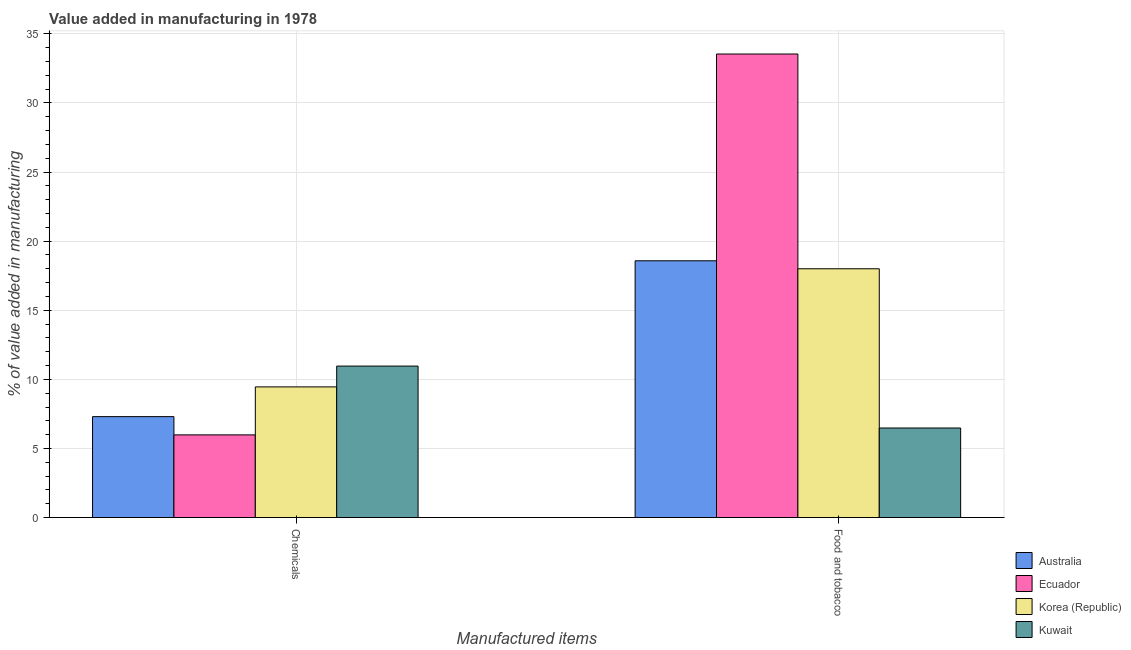How many groups of bars are there?
Give a very brief answer. 2. Are the number of bars on each tick of the X-axis equal?
Your answer should be compact. Yes. What is the label of the 2nd group of bars from the left?
Offer a very short reply. Food and tobacco. What is the value added by  manufacturing chemicals in Australia?
Offer a very short reply. 7.3. Across all countries, what is the maximum value added by  manufacturing chemicals?
Your answer should be very brief. 10.96. Across all countries, what is the minimum value added by  manufacturing chemicals?
Make the answer very short. 5.98. In which country was the value added by  manufacturing chemicals maximum?
Keep it short and to the point. Kuwait. In which country was the value added by  manufacturing chemicals minimum?
Your answer should be very brief. Ecuador. What is the total value added by  manufacturing chemicals in the graph?
Provide a short and direct response. 33.7. What is the difference between the value added by  manufacturing chemicals in Australia and that in Kuwait?
Offer a very short reply. -3.66. What is the difference between the value added by  manufacturing chemicals in Korea (Republic) and the value added by manufacturing food and tobacco in Australia?
Ensure brevity in your answer.  -9.12. What is the average value added by  manufacturing chemicals per country?
Offer a very short reply. 8.43. What is the difference between the value added by  manufacturing chemicals and value added by manufacturing food and tobacco in Kuwait?
Make the answer very short. 4.48. What is the ratio of the value added by manufacturing food and tobacco in Australia to that in Ecuador?
Provide a short and direct response. 0.55. What does the 2nd bar from the left in Chemicals represents?
Ensure brevity in your answer.  Ecuador. What is the difference between two consecutive major ticks on the Y-axis?
Provide a succinct answer. 5. Does the graph contain any zero values?
Your answer should be compact. No. Does the graph contain grids?
Your response must be concise. Yes. What is the title of the graph?
Your answer should be very brief. Value added in manufacturing in 1978. Does "Uzbekistan" appear as one of the legend labels in the graph?
Keep it short and to the point. No. What is the label or title of the X-axis?
Offer a terse response. Manufactured items. What is the label or title of the Y-axis?
Give a very brief answer. % of value added in manufacturing. What is the % of value added in manufacturing in Australia in Chemicals?
Your response must be concise. 7.3. What is the % of value added in manufacturing in Ecuador in Chemicals?
Offer a terse response. 5.98. What is the % of value added in manufacturing in Korea (Republic) in Chemicals?
Give a very brief answer. 9.46. What is the % of value added in manufacturing of Kuwait in Chemicals?
Provide a succinct answer. 10.96. What is the % of value added in manufacturing of Australia in Food and tobacco?
Your answer should be compact. 18.58. What is the % of value added in manufacturing of Ecuador in Food and tobacco?
Provide a short and direct response. 33.54. What is the % of value added in manufacturing of Korea (Republic) in Food and tobacco?
Give a very brief answer. 18. What is the % of value added in manufacturing in Kuwait in Food and tobacco?
Make the answer very short. 6.48. Across all Manufactured items, what is the maximum % of value added in manufacturing in Australia?
Keep it short and to the point. 18.58. Across all Manufactured items, what is the maximum % of value added in manufacturing of Ecuador?
Provide a short and direct response. 33.54. Across all Manufactured items, what is the maximum % of value added in manufacturing of Korea (Republic)?
Your answer should be compact. 18. Across all Manufactured items, what is the maximum % of value added in manufacturing of Kuwait?
Your answer should be very brief. 10.96. Across all Manufactured items, what is the minimum % of value added in manufacturing of Australia?
Your answer should be compact. 7.3. Across all Manufactured items, what is the minimum % of value added in manufacturing of Ecuador?
Make the answer very short. 5.98. Across all Manufactured items, what is the minimum % of value added in manufacturing in Korea (Republic)?
Your answer should be compact. 9.46. Across all Manufactured items, what is the minimum % of value added in manufacturing in Kuwait?
Make the answer very short. 6.48. What is the total % of value added in manufacturing in Australia in the graph?
Your response must be concise. 25.88. What is the total % of value added in manufacturing of Ecuador in the graph?
Ensure brevity in your answer.  39.53. What is the total % of value added in manufacturing of Korea (Republic) in the graph?
Provide a succinct answer. 27.46. What is the total % of value added in manufacturing in Kuwait in the graph?
Your answer should be compact. 17.44. What is the difference between the % of value added in manufacturing in Australia in Chemicals and that in Food and tobacco?
Provide a short and direct response. -11.28. What is the difference between the % of value added in manufacturing of Ecuador in Chemicals and that in Food and tobacco?
Your answer should be very brief. -27.56. What is the difference between the % of value added in manufacturing of Korea (Republic) in Chemicals and that in Food and tobacco?
Give a very brief answer. -8.55. What is the difference between the % of value added in manufacturing of Kuwait in Chemicals and that in Food and tobacco?
Provide a succinct answer. 4.48. What is the difference between the % of value added in manufacturing of Australia in Chemicals and the % of value added in manufacturing of Ecuador in Food and tobacco?
Your answer should be very brief. -26.24. What is the difference between the % of value added in manufacturing of Australia in Chemicals and the % of value added in manufacturing of Korea (Republic) in Food and tobacco?
Offer a very short reply. -10.7. What is the difference between the % of value added in manufacturing of Australia in Chemicals and the % of value added in manufacturing of Kuwait in Food and tobacco?
Give a very brief answer. 0.82. What is the difference between the % of value added in manufacturing of Ecuador in Chemicals and the % of value added in manufacturing of Korea (Republic) in Food and tobacco?
Your answer should be very brief. -12.02. What is the difference between the % of value added in manufacturing of Ecuador in Chemicals and the % of value added in manufacturing of Kuwait in Food and tobacco?
Give a very brief answer. -0.5. What is the difference between the % of value added in manufacturing in Korea (Republic) in Chemicals and the % of value added in manufacturing in Kuwait in Food and tobacco?
Ensure brevity in your answer.  2.98. What is the average % of value added in manufacturing in Australia per Manufactured items?
Provide a short and direct response. 12.94. What is the average % of value added in manufacturing in Ecuador per Manufactured items?
Provide a succinct answer. 19.76. What is the average % of value added in manufacturing of Korea (Republic) per Manufactured items?
Offer a terse response. 13.73. What is the average % of value added in manufacturing of Kuwait per Manufactured items?
Ensure brevity in your answer.  8.72. What is the difference between the % of value added in manufacturing in Australia and % of value added in manufacturing in Ecuador in Chemicals?
Your answer should be very brief. 1.32. What is the difference between the % of value added in manufacturing of Australia and % of value added in manufacturing of Korea (Republic) in Chemicals?
Your response must be concise. -2.15. What is the difference between the % of value added in manufacturing in Australia and % of value added in manufacturing in Kuwait in Chemicals?
Your answer should be very brief. -3.66. What is the difference between the % of value added in manufacturing in Ecuador and % of value added in manufacturing in Korea (Republic) in Chemicals?
Make the answer very short. -3.47. What is the difference between the % of value added in manufacturing of Ecuador and % of value added in manufacturing of Kuwait in Chemicals?
Ensure brevity in your answer.  -4.98. What is the difference between the % of value added in manufacturing of Korea (Republic) and % of value added in manufacturing of Kuwait in Chemicals?
Keep it short and to the point. -1.51. What is the difference between the % of value added in manufacturing in Australia and % of value added in manufacturing in Ecuador in Food and tobacco?
Offer a very short reply. -14.96. What is the difference between the % of value added in manufacturing in Australia and % of value added in manufacturing in Korea (Republic) in Food and tobacco?
Your answer should be compact. 0.58. What is the difference between the % of value added in manufacturing in Australia and % of value added in manufacturing in Kuwait in Food and tobacco?
Your answer should be very brief. 12.1. What is the difference between the % of value added in manufacturing in Ecuador and % of value added in manufacturing in Korea (Republic) in Food and tobacco?
Ensure brevity in your answer.  15.54. What is the difference between the % of value added in manufacturing of Ecuador and % of value added in manufacturing of Kuwait in Food and tobacco?
Your response must be concise. 27.06. What is the difference between the % of value added in manufacturing in Korea (Republic) and % of value added in manufacturing in Kuwait in Food and tobacco?
Your response must be concise. 11.52. What is the ratio of the % of value added in manufacturing in Australia in Chemicals to that in Food and tobacco?
Keep it short and to the point. 0.39. What is the ratio of the % of value added in manufacturing in Ecuador in Chemicals to that in Food and tobacco?
Ensure brevity in your answer.  0.18. What is the ratio of the % of value added in manufacturing in Korea (Republic) in Chemicals to that in Food and tobacco?
Provide a succinct answer. 0.53. What is the ratio of the % of value added in manufacturing in Kuwait in Chemicals to that in Food and tobacco?
Give a very brief answer. 1.69. What is the difference between the highest and the second highest % of value added in manufacturing in Australia?
Your response must be concise. 11.28. What is the difference between the highest and the second highest % of value added in manufacturing in Ecuador?
Ensure brevity in your answer.  27.56. What is the difference between the highest and the second highest % of value added in manufacturing of Korea (Republic)?
Offer a terse response. 8.55. What is the difference between the highest and the second highest % of value added in manufacturing of Kuwait?
Your answer should be compact. 4.48. What is the difference between the highest and the lowest % of value added in manufacturing in Australia?
Provide a succinct answer. 11.28. What is the difference between the highest and the lowest % of value added in manufacturing in Ecuador?
Ensure brevity in your answer.  27.56. What is the difference between the highest and the lowest % of value added in manufacturing of Korea (Republic)?
Your response must be concise. 8.55. What is the difference between the highest and the lowest % of value added in manufacturing in Kuwait?
Your answer should be compact. 4.48. 